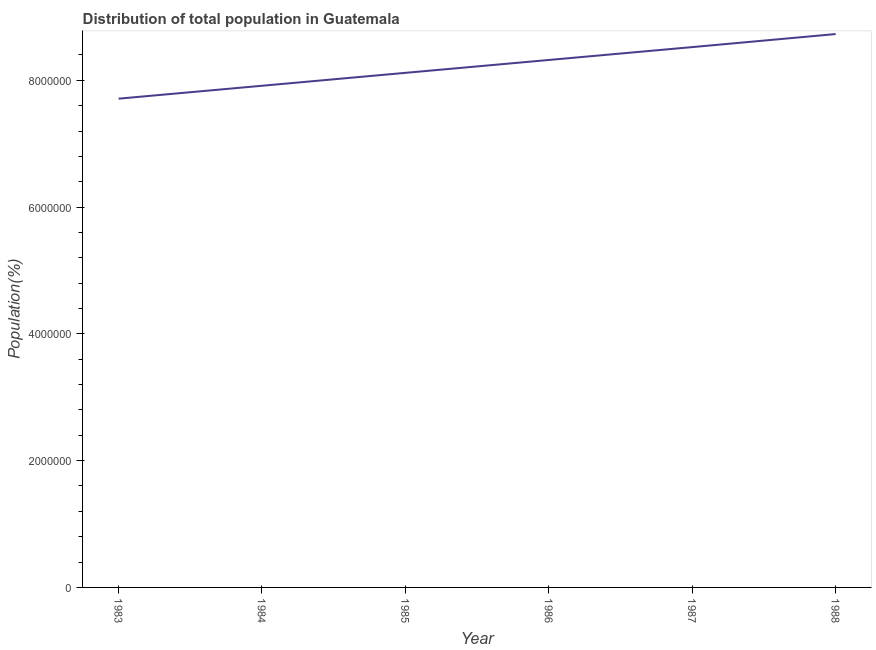What is the population in 1987?
Provide a succinct answer. 8.52e+06. Across all years, what is the maximum population?
Offer a very short reply. 8.73e+06. Across all years, what is the minimum population?
Keep it short and to the point. 7.71e+06. In which year was the population minimum?
Ensure brevity in your answer.  1983. What is the sum of the population?
Your response must be concise. 4.93e+07. What is the difference between the population in 1984 and 1986?
Keep it short and to the point. -4.07e+05. What is the average population per year?
Make the answer very short. 8.22e+06. What is the median population?
Give a very brief answer. 8.22e+06. In how many years, is the population greater than 5600000 %?
Provide a succinct answer. 6. Do a majority of the years between 1986 and 1983 (inclusive) have population greater than 7200000 %?
Provide a succinct answer. Yes. What is the ratio of the population in 1983 to that in 1988?
Your answer should be very brief. 0.88. What is the difference between the highest and the second highest population?
Ensure brevity in your answer.  2.06e+05. Is the sum of the population in 1987 and 1988 greater than the maximum population across all years?
Offer a terse response. Yes. What is the difference between the highest and the lowest population?
Make the answer very short. 1.02e+06. How many lines are there?
Offer a very short reply. 1. Does the graph contain any zero values?
Your answer should be compact. No. Does the graph contain grids?
Provide a succinct answer. No. What is the title of the graph?
Keep it short and to the point. Distribution of total population in Guatemala . What is the label or title of the X-axis?
Give a very brief answer. Year. What is the label or title of the Y-axis?
Provide a short and direct response. Population(%). What is the Population(%) in 1983?
Provide a succinct answer. 7.71e+06. What is the Population(%) in 1984?
Your response must be concise. 7.91e+06. What is the Population(%) in 1985?
Your answer should be very brief. 8.12e+06. What is the Population(%) of 1986?
Provide a short and direct response. 8.32e+06. What is the Population(%) of 1987?
Your response must be concise. 8.52e+06. What is the Population(%) in 1988?
Your answer should be compact. 8.73e+06. What is the difference between the Population(%) in 1983 and 1984?
Provide a succinct answer. -2.04e+05. What is the difference between the Population(%) in 1983 and 1985?
Provide a short and direct response. -4.07e+05. What is the difference between the Population(%) in 1983 and 1986?
Offer a very short reply. -6.10e+05. What is the difference between the Population(%) in 1983 and 1987?
Provide a succinct answer. -8.14e+05. What is the difference between the Population(%) in 1983 and 1988?
Your answer should be very brief. -1.02e+06. What is the difference between the Population(%) in 1984 and 1985?
Your answer should be very brief. -2.04e+05. What is the difference between the Population(%) in 1984 and 1986?
Provide a short and direct response. -4.07e+05. What is the difference between the Population(%) in 1984 and 1987?
Provide a succinct answer. -6.10e+05. What is the difference between the Population(%) in 1984 and 1988?
Offer a very short reply. -8.16e+05. What is the difference between the Population(%) in 1985 and 1986?
Keep it short and to the point. -2.03e+05. What is the difference between the Population(%) in 1985 and 1987?
Ensure brevity in your answer.  -4.06e+05. What is the difference between the Population(%) in 1985 and 1988?
Make the answer very short. -6.12e+05. What is the difference between the Population(%) in 1986 and 1987?
Give a very brief answer. -2.03e+05. What is the difference between the Population(%) in 1986 and 1988?
Give a very brief answer. -4.09e+05. What is the difference between the Population(%) in 1987 and 1988?
Provide a short and direct response. -2.06e+05. What is the ratio of the Population(%) in 1983 to that in 1984?
Your answer should be very brief. 0.97. What is the ratio of the Population(%) in 1983 to that in 1986?
Offer a very short reply. 0.93. What is the ratio of the Population(%) in 1983 to that in 1987?
Provide a succinct answer. 0.91. What is the ratio of the Population(%) in 1983 to that in 1988?
Make the answer very short. 0.88. What is the ratio of the Population(%) in 1984 to that in 1986?
Your response must be concise. 0.95. What is the ratio of the Population(%) in 1984 to that in 1987?
Your response must be concise. 0.93. What is the ratio of the Population(%) in 1984 to that in 1988?
Your answer should be compact. 0.91. What is the ratio of the Population(%) in 1985 to that in 1987?
Give a very brief answer. 0.95. What is the ratio of the Population(%) in 1986 to that in 1988?
Your answer should be compact. 0.95. What is the ratio of the Population(%) in 1987 to that in 1988?
Keep it short and to the point. 0.98. 